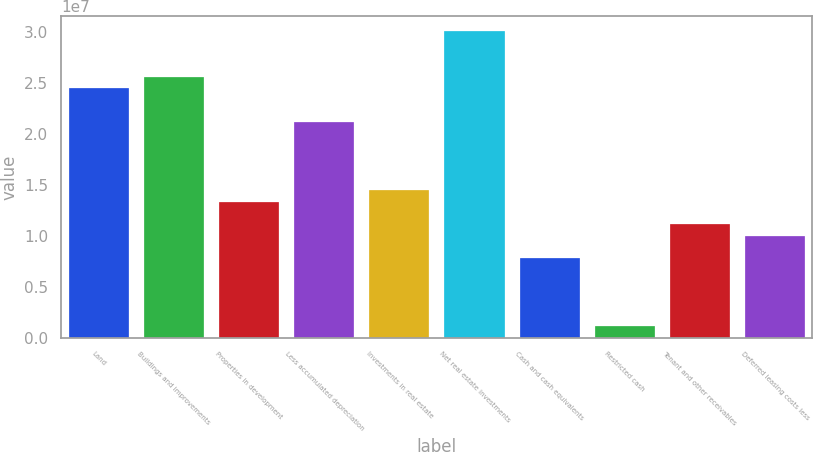Convert chart to OTSL. <chart><loc_0><loc_0><loc_500><loc_500><bar_chart><fcel>Land<fcel>Buildings and improvements<fcel>Properties in development<fcel>Less accumulated depreciation<fcel>Investments in real estate<fcel>Net real estate investments<fcel>Cash and cash equivalents<fcel>Restricted cash<fcel>Tenant and other receivables<fcel>Deferred leasing costs less<nl><fcel>2.45185e+07<fcel>2.56329e+07<fcel>1.33745e+07<fcel>2.11753e+07<fcel>1.44889e+07<fcel>3.00905e+07<fcel>7.80252e+06<fcel>1.11611e+06<fcel>1.11457e+07<fcel>1.00313e+07<nl></chart> 